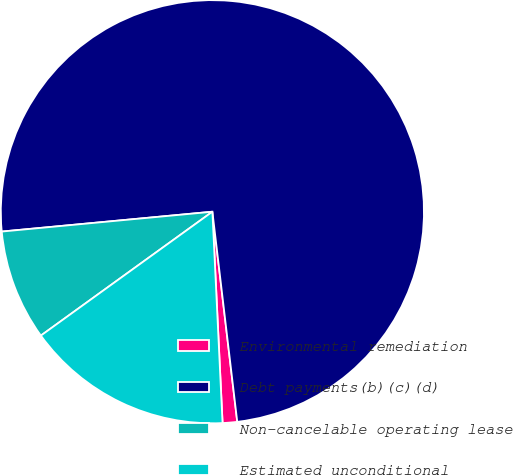Convert chart. <chart><loc_0><loc_0><loc_500><loc_500><pie_chart><fcel>Environmental remediation<fcel>Debt payments(b)(c)(d)<fcel>Non-cancelable operating lease<fcel>Estimated unconditional<nl><fcel>1.11%<fcel>74.62%<fcel>8.46%<fcel>15.81%<nl></chart> 